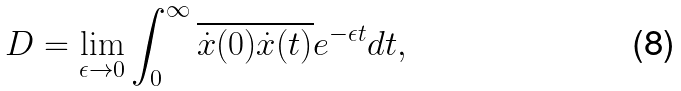Convert formula to latex. <formula><loc_0><loc_0><loc_500><loc_500>D = \lim _ { \epsilon \to 0 } \int _ { 0 } ^ { \infty } \overline { \dot { x } ( 0 ) \dot { x } ( t ) } e ^ { - \epsilon t } d t ,</formula> 